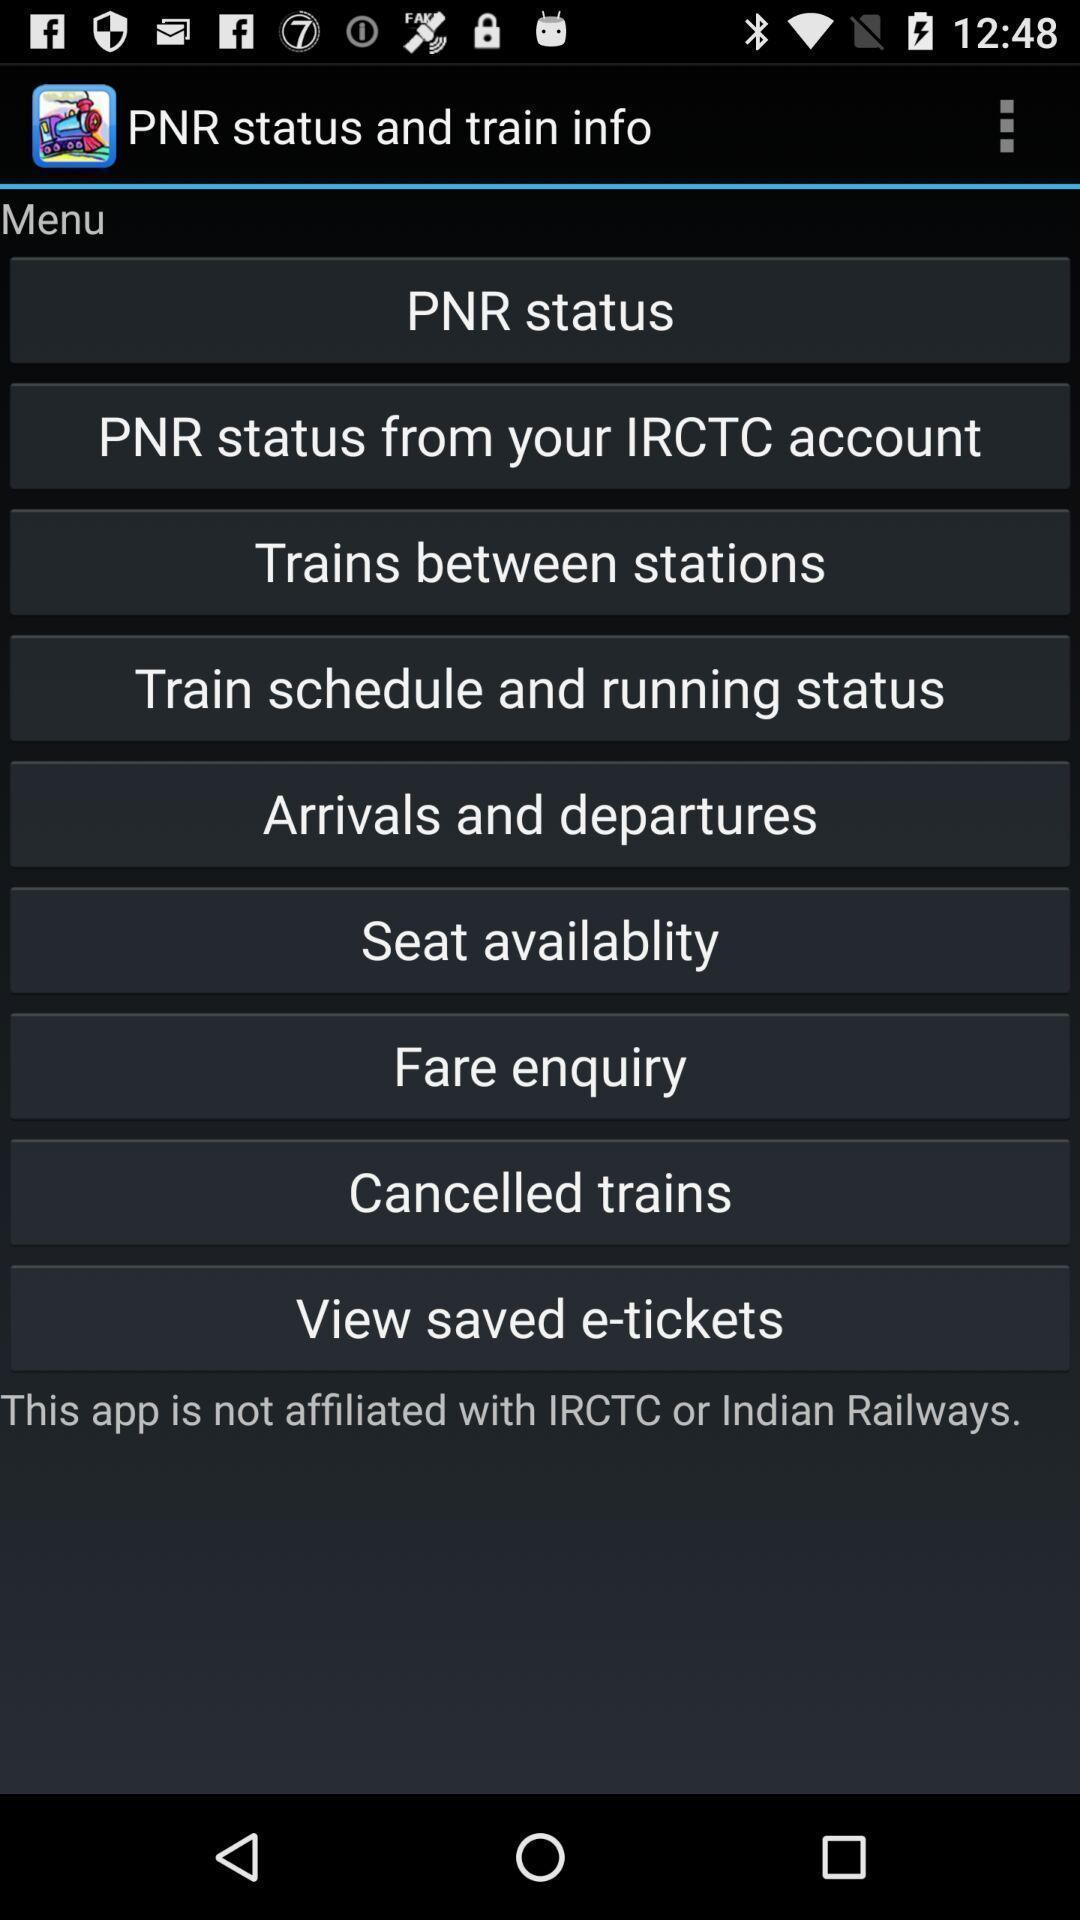Summarize the information in this screenshot. Page showing different option about trains. 